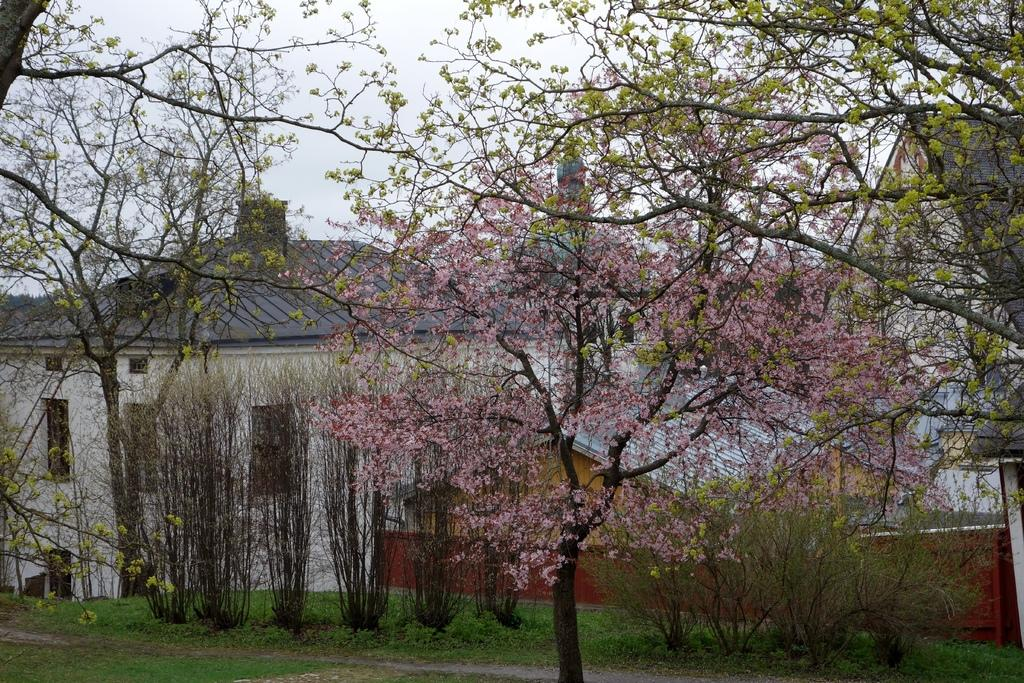What type of vegetation is at the bottom of the image? There is grass at the bottom of the image. What can be seen in the middle of the image? There are trees in the middle of the image. What type of structures are visible in the background of the image? There are houses in the background of the image. What is visible at the top of the image? The sky is visible at the top of the image. What is the name of the wren perched on the tree in the image? There is no wren present in the image; it only features grass, trees, houses, and the sky. 